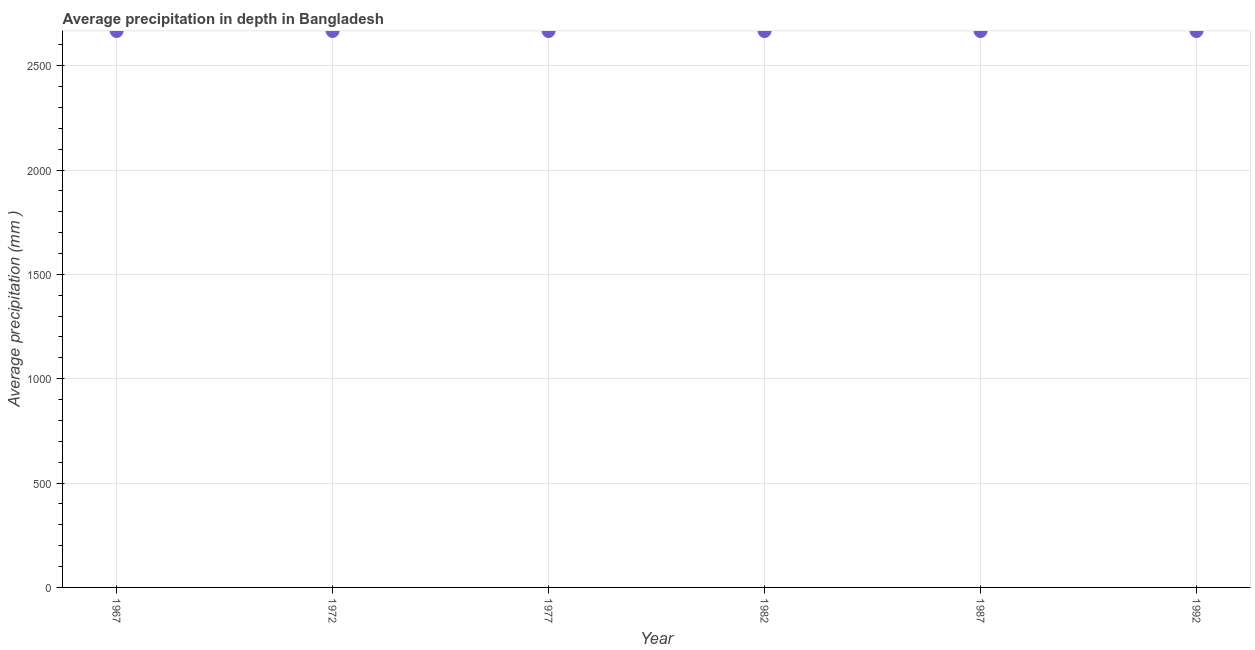What is the average precipitation in depth in 1977?
Your answer should be compact. 2666. Across all years, what is the maximum average precipitation in depth?
Offer a terse response. 2666. Across all years, what is the minimum average precipitation in depth?
Your response must be concise. 2666. In which year was the average precipitation in depth maximum?
Ensure brevity in your answer.  1967. In which year was the average precipitation in depth minimum?
Provide a succinct answer. 1967. What is the sum of the average precipitation in depth?
Provide a short and direct response. 1.60e+04. What is the average average precipitation in depth per year?
Ensure brevity in your answer.  2666. What is the median average precipitation in depth?
Your answer should be very brief. 2666. Do a majority of the years between 1967 and 1992 (inclusive) have average precipitation in depth greater than 100 mm?
Give a very brief answer. Yes. Is the difference between the average precipitation in depth in 1967 and 1972 greater than the difference between any two years?
Ensure brevity in your answer.  Yes. Is the sum of the average precipitation in depth in 1972 and 1992 greater than the maximum average precipitation in depth across all years?
Offer a very short reply. Yes. What is the difference between the highest and the lowest average precipitation in depth?
Provide a short and direct response. 0. How many dotlines are there?
Your response must be concise. 1. Does the graph contain any zero values?
Your response must be concise. No. Does the graph contain grids?
Your answer should be compact. Yes. What is the title of the graph?
Make the answer very short. Average precipitation in depth in Bangladesh. What is the label or title of the X-axis?
Keep it short and to the point. Year. What is the label or title of the Y-axis?
Make the answer very short. Average precipitation (mm ). What is the Average precipitation (mm ) in 1967?
Offer a very short reply. 2666. What is the Average precipitation (mm ) in 1972?
Offer a very short reply. 2666. What is the Average precipitation (mm ) in 1977?
Ensure brevity in your answer.  2666. What is the Average precipitation (mm ) in 1982?
Provide a short and direct response. 2666. What is the Average precipitation (mm ) in 1987?
Offer a terse response. 2666. What is the Average precipitation (mm ) in 1992?
Make the answer very short. 2666. What is the difference between the Average precipitation (mm ) in 1967 and 1977?
Provide a short and direct response. 0. What is the difference between the Average precipitation (mm ) in 1967 and 1992?
Provide a short and direct response. 0. What is the difference between the Average precipitation (mm ) in 1972 and 1977?
Offer a very short reply. 0. What is the difference between the Average precipitation (mm ) in 1972 and 1982?
Make the answer very short. 0. What is the difference between the Average precipitation (mm ) in 1972 and 1987?
Your answer should be very brief. 0. What is the difference between the Average precipitation (mm ) in 1972 and 1992?
Give a very brief answer. 0. What is the difference between the Average precipitation (mm ) in 1977 and 1987?
Ensure brevity in your answer.  0. What is the difference between the Average precipitation (mm ) in 1977 and 1992?
Ensure brevity in your answer.  0. What is the difference between the Average precipitation (mm ) in 1987 and 1992?
Ensure brevity in your answer.  0. What is the ratio of the Average precipitation (mm ) in 1967 to that in 1972?
Give a very brief answer. 1. What is the ratio of the Average precipitation (mm ) in 1967 to that in 1977?
Make the answer very short. 1. What is the ratio of the Average precipitation (mm ) in 1967 to that in 1982?
Provide a succinct answer. 1. What is the ratio of the Average precipitation (mm ) in 1967 to that in 1987?
Make the answer very short. 1. What is the ratio of the Average precipitation (mm ) in 1972 to that in 1982?
Offer a terse response. 1. What is the ratio of the Average precipitation (mm ) in 1972 to that in 1987?
Make the answer very short. 1. What is the ratio of the Average precipitation (mm ) in 1977 to that in 1982?
Provide a short and direct response. 1. What is the ratio of the Average precipitation (mm ) in 1977 to that in 1992?
Offer a very short reply. 1. What is the ratio of the Average precipitation (mm ) in 1982 to that in 1992?
Keep it short and to the point. 1. What is the ratio of the Average precipitation (mm ) in 1987 to that in 1992?
Give a very brief answer. 1. 